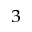<formula> <loc_0><loc_0><loc_500><loc_500>^ { 3 }</formula> 